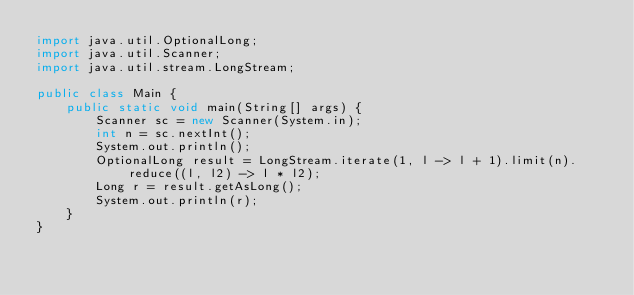Convert code to text. <code><loc_0><loc_0><loc_500><loc_500><_Java_>import java.util.OptionalLong;
import java.util.Scanner;
import java.util.stream.LongStream;

public class Main {
    public static void main(String[] args) {
        Scanner sc = new Scanner(System.in);
        int n = sc.nextInt();
        System.out.println();
        OptionalLong result = LongStream.iterate(1, l -> l + 1).limit(n).reduce((l, l2) -> l * l2);
        Long r = result.getAsLong();
        System.out.println(r);
    }
}</code> 